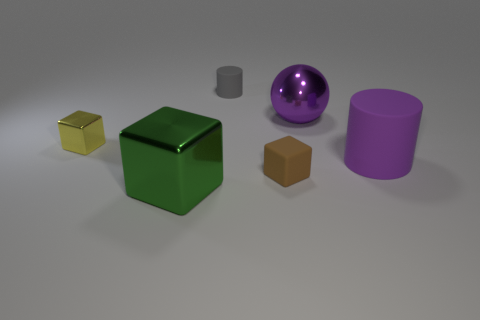What is the material of the purple cylinder that is the same size as the green thing?
Provide a short and direct response. Rubber. How many things are either large red cylinders or tiny rubber objects that are behind the yellow block?
Ensure brevity in your answer.  1. Does the purple metallic sphere have the same size as the shiny block that is behind the tiny brown object?
Ensure brevity in your answer.  No. How many blocks are large gray matte objects or brown matte objects?
Make the answer very short. 1. How many big objects are both to the right of the big purple metal thing and in front of the brown cube?
Ensure brevity in your answer.  0. How many other objects are there of the same color as the tiny cylinder?
Give a very brief answer. 0. There is a big object to the left of the tiny brown rubber block; what shape is it?
Your answer should be compact. Cube. Is the material of the big cylinder the same as the green object?
Your answer should be very brief. No. Is there any other thing that is the same size as the green metal block?
Make the answer very short. Yes. How many balls are in front of the purple metallic thing?
Your response must be concise. 0. 